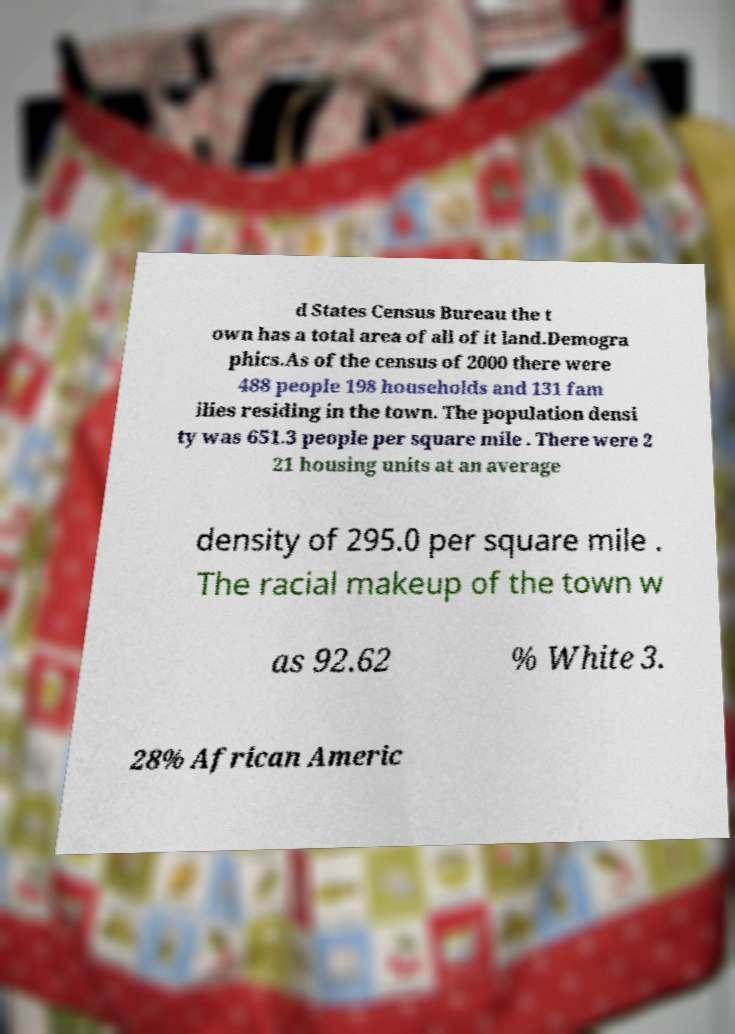Please identify and transcribe the text found in this image. d States Census Bureau the t own has a total area of all of it land.Demogra phics.As of the census of 2000 there were 488 people 198 households and 131 fam ilies residing in the town. The population densi ty was 651.3 people per square mile . There were 2 21 housing units at an average density of 295.0 per square mile . The racial makeup of the town w as 92.62 % White 3. 28% African Americ 